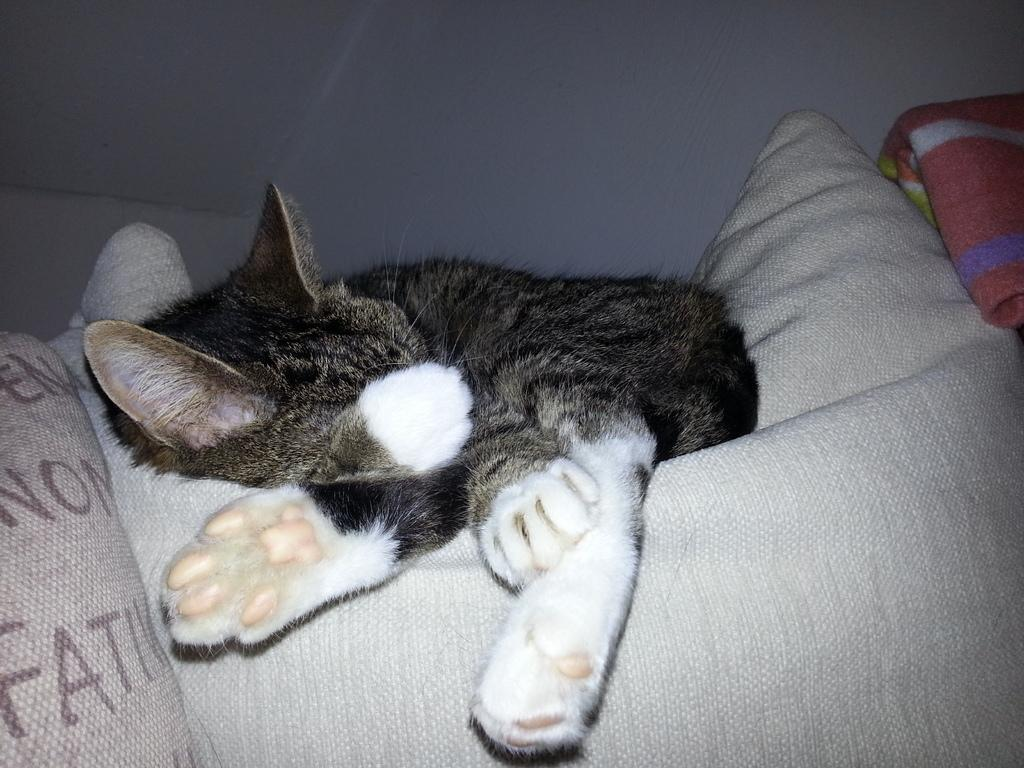What animal is in the image? There is a cat in the image. Where is the cat located in the image? The cat is in the center of the image. What is the cat doing in the image? The cat is sleeping on a bed. What type of instrument is the cat playing in the image? There is no instrument present in the image, and the cat is not playing any instrument. 